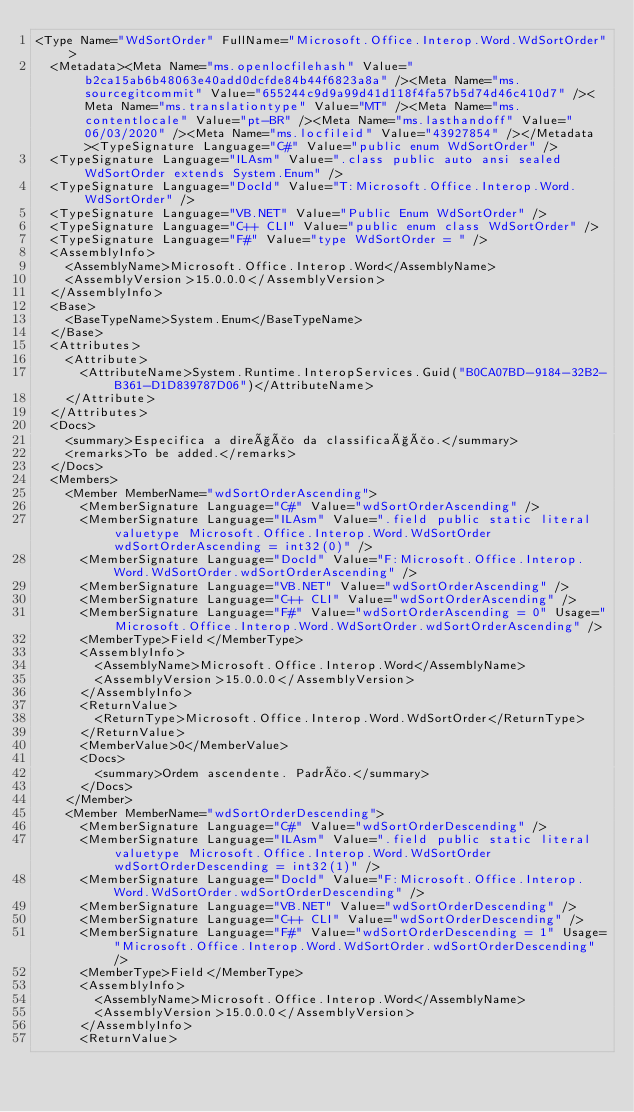Convert code to text. <code><loc_0><loc_0><loc_500><loc_500><_XML_><Type Name="WdSortOrder" FullName="Microsoft.Office.Interop.Word.WdSortOrder">
  <Metadata><Meta Name="ms.openlocfilehash" Value="b2ca15ab6b48063e40add0dcfde84b44f6823a8a" /><Meta Name="ms.sourcegitcommit" Value="655244c9d9a99d41d118f4fa57b5d74d46c410d7" /><Meta Name="ms.translationtype" Value="MT" /><Meta Name="ms.contentlocale" Value="pt-BR" /><Meta Name="ms.lasthandoff" Value="06/03/2020" /><Meta Name="ms.locfileid" Value="43927854" /></Metadata><TypeSignature Language="C#" Value="public enum WdSortOrder" />
  <TypeSignature Language="ILAsm" Value=".class public auto ansi sealed WdSortOrder extends System.Enum" />
  <TypeSignature Language="DocId" Value="T:Microsoft.Office.Interop.Word.WdSortOrder" />
  <TypeSignature Language="VB.NET" Value="Public Enum WdSortOrder" />
  <TypeSignature Language="C++ CLI" Value="public enum class WdSortOrder" />
  <TypeSignature Language="F#" Value="type WdSortOrder = " />
  <AssemblyInfo>
    <AssemblyName>Microsoft.Office.Interop.Word</AssemblyName>
    <AssemblyVersion>15.0.0.0</AssemblyVersion>
  </AssemblyInfo>
  <Base>
    <BaseTypeName>System.Enum</BaseTypeName>
  </Base>
  <Attributes>
    <Attribute>
      <AttributeName>System.Runtime.InteropServices.Guid("B0CA07BD-9184-32B2-B361-D1D839787D06")</AttributeName>
    </Attribute>
  </Attributes>
  <Docs>
    <summary>Especifica a direção da classificação.</summary>
    <remarks>To be added.</remarks>
  </Docs>
  <Members>
    <Member MemberName="wdSortOrderAscending">
      <MemberSignature Language="C#" Value="wdSortOrderAscending" />
      <MemberSignature Language="ILAsm" Value=".field public static literal valuetype Microsoft.Office.Interop.Word.WdSortOrder wdSortOrderAscending = int32(0)" />
      <MemberSignature Language="DocId" Value="F:Microsoft.Office.Interop.Word.WdSortOrder.wdSortOrderAscending" />
      <MemberSignature Language="VB.NET" Value="wdSortOrderAscending" />
      <MemberSignature Language="C++ CLI" Value="wdSortOrderAscending" />
      <MemberSignature Language="F#" Value="wdSortOrderAscending = 0" Usage="Microsoft.Office.Interop.Word.WdSortOrder.wdSortOrderAscending" />
      <MemberType>Field</MemberType>
      <AssemblyInfo>
        <AssemblyName>Microsoft.Office.Interop.Word</AssemblyName>
        <AssemblyVersion>15.0.0.0</AssemblyVersion>
      </AssemblyInfo>
      <ReturnValue>
        <ReturnType>Microsoft.Office.Interop.Word.WdSortOrder</ReturnType>
      </ReturnValue>
      <MemberValue>0</MemberValue>
      <Docs>
        <summary>Ordem ascendente. Padrão.</summary>
      </Docs>
    </Member>
    <Member MemberName="wdSortOrderDescending">
      <MemberSignature Language="C#" Value="wdSortOrderDescending" />
      <MemberSignature Language="ILAsm" Value=".field public static literal valuetype Microsoft.Office.Interop.Word.WdSortOrder wdSortOrderDescending = int32(1)" />
      <MemberSignature Language="DocId" Value="F:Microsoft.Office.Interop.Word.WdSortOrder.wdSortOrderDescending" />
      <MemberSignature Language="VB.NET" Value="wdSortOrderDescending" />
      <MemberSignature Language="C++ CLI" Value="wdSortOrderDescending" />
      <MemberSignature Language="F#" Value="wdSortOrderDescending = 1" Usage="Microsoft.Office.Interop.Word.WdSortOrder.wdSortOrderDescending" />
      <MemberType>Field</MemberType>
      <AssemblyInfo>
        <AssemblyName>Microsoft.Office.Interop.Word</AssemblyName>
        <AssemblyVersion>15.0.0.0</AssemblyVersion>
      </AssemblyInfo>
      <ReturnValue></code> 